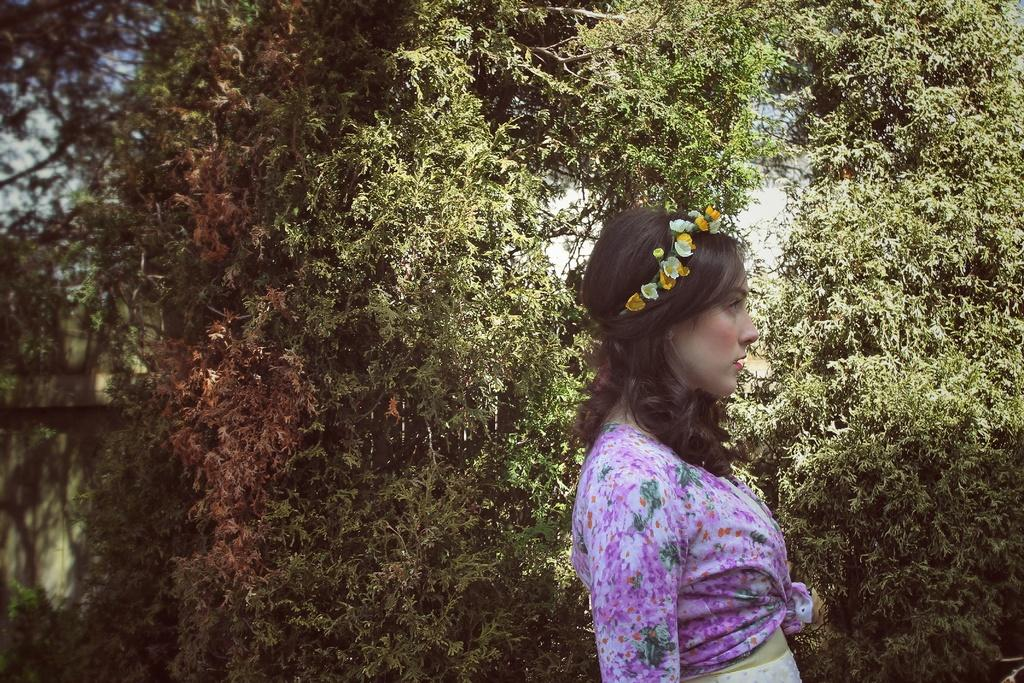Who is present in the image? There is a woman in the image. What is the woman doing in the image? The woman is standing on the ground in the image. What is the woman wearing on her head? The woman is wearing a tiara in the image. What can be seen in the background of the image? There are trees and the sky visible in the background of the image. What type of paint is being used by the woman in the image? There is no paint or painting activity present in the image. Can you solve the riddle that the woman is holding in the image? There is no riddle visible in the image. 